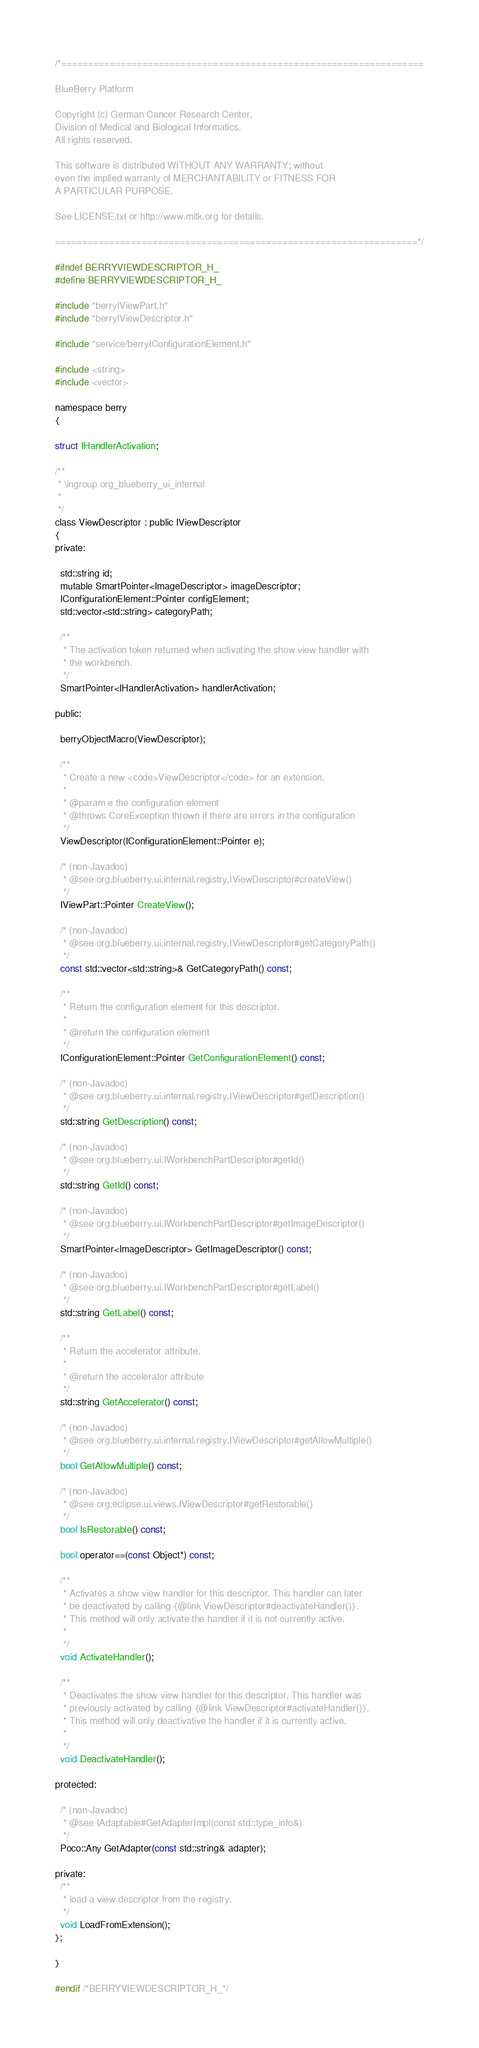<code> <loc_0><loc_0><loc_500><loc_500><_C_>/*===================================================================

BlueBerry Platform

Copyright (c) German Cancer Research Center,
Division of Medical and Biological Informatics.
All rights reserved.

This software is distributed WITHOUT ANY WARRANTY; without
even the implied warranty of MERCHANTABILITY or FITNESS FOR
A PARTICULAR PURPOSE.

See LICENSE.txt or http://www.mitk.org for details.

===================================================================*/

#ifndef BERRYVIEWDESCRIPTOR_H_
#define BERRYVIEWDESCRIPTOR_H_

#include "berryIViewPart.h"
#include "berryIViewDescriptor.h"

#include "service/berryIConfigurationElement.h"

#include <string>
#include <vector>

namespace berry
{

struct IHandlerActivation;

/**
 * \ingroup org_blueberry_ui_internal
 *
 */
class ViewDescriptor : public IViewDescriptor
{
private:

  std::string id;
  mutable SmartPointer<ImageDescriptor> imageDescriptor;
  IConfigurationElement::Pointer configElement;
  std::vector<std::string> categoryPath;

  /**
   * The activation token returned when activating the show view handler with
   * the workbench.
   */
  SmartPointer<IHandlerActivation> handlerActivation;

public:

  berryObjectMacro(ViewDescriptor);

  /**
   * Create a new <code>ViewDescriptor</code> for an extension.
   *
   * @param e the configuration element
   * @throws CoreException thrown if there are errors in the configuration
   */
  ViewDescriptor(IConfigurationElement::Pointer e);

  /* (non-Javadoc)
   * @see org.blueberry.ui.internal.registry.IViewDescriptor#createView()
   */
  IViewPart::Pointer CreateView();

  /* (non-Javadoc)
   * @see org.blueberry.ui.internal.registry.IViewDescriptor#getCategoryPath()
   */
  const std::vector<std::string>& GetCategoryPath() const;

  /**
   * Return the configuration element for this descriptor.
   *
   * @return the configuration element
   */
  IConfigurationElement::Pointer GetConfigurationElement() const;

  /* (non-Javadoc)
   * @see org.blueberry.ui.internal.registry.IViewDescriptor#getDescription()
   */
  std::string GetDescription() const;

  /* (non-Javadoc)
   * @see org.blueberry.ui.IWorkbenchPartDescriptor#getId()
   */
  std::string GetId() const;

  /* (non-Javadoc)
   * @see org.blueberry.ui.IWorkbenchPartDescriptor#getImageDescriptor()
   */
  SmartPointer<ImageDescriptor> GetImageDescriptor() const;

  /* (non-Javadoc)
   * @see org.blueberry.ui.IWorkbenchPartDescriptor#getLabel()
   */
  std::string GetLabel() const;

  /**
   * Return the accelerator attribute.
   *
   * @return the accelerator attribute
   */
  std::string GetAccelerator() const;

  /* (non-Javadoc)
   * @see org.blueberry.ui.internal.registry.IViewDescriptor#getAllowMultiple()
   */
  bool GetAllowMultiple() const;

  /* (non-Javadoc)
   * @see org.eclipse.ui.views.IViewDescriptor#getRestorable()
   */
  bool IsRestorable() const;

  bool operator==(const Object*) const;

  /**
   * Activates a show view handler for this descriptor. This handler can later
   * be deactivated by calling {@link ViewDescriptor#deactivateHandler()}.
   * This method will only activate the handler if it is not currently active.
   *
   */
  void ActivateHandler();

  /**
   * Deactivates the show view handler for this descriptor. This handler was
   * previously activated by calling {@link ViewDescriptor#activateHandler()}.
   * This method will only deactivative the handler if it is currently active.
   *
   */
  void DeactivateHandler();

protected:

  /* (non-Javadoc)
   * @see IAdaptable#GetAdapterImpl(const std::type_info&)
   */
  Poco::Any GetAdapter(const std::string& adapter);

private:
  /**
   * load a view descriptor from the registry.
   */
  void LoadFromExtension();
};

}

#endif /*BERRYVIEWDESCRIPTOR_H_*/
</code> 